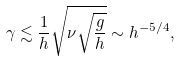Convert formula to latex. <formula><loc_0><loc_0><loc_500><loc_500>\gamma \lesssim \frac { 1 } { h } \sqrt { \nu \sqrt { \frac { g } { h } } } \sim h ^ { - 5 / 4 } ,</formula> 